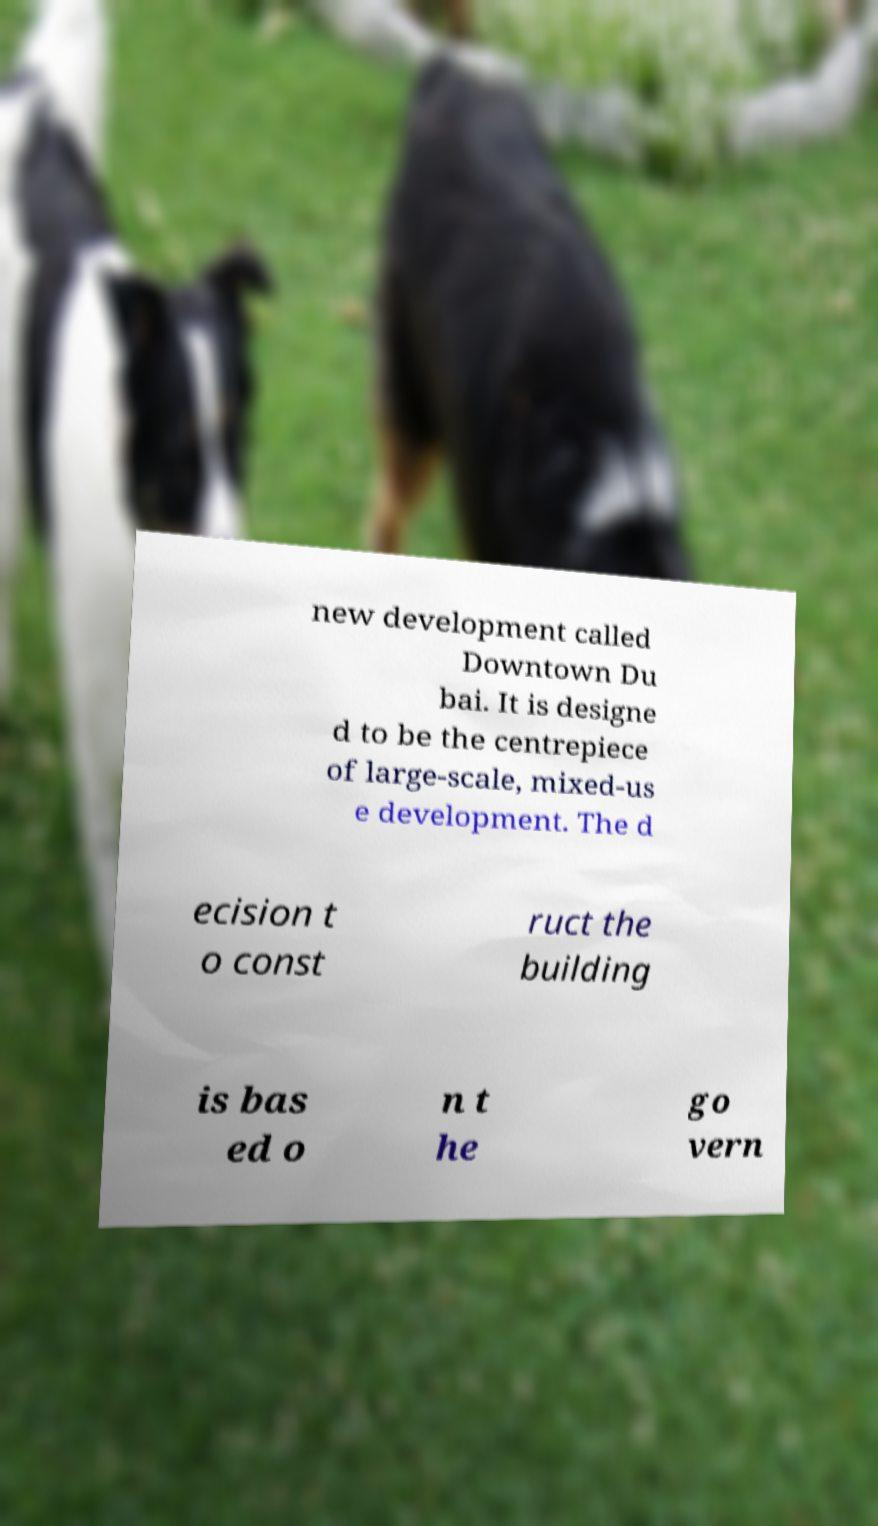Could you assist in decoding the text presented in this image and type it out clearly? new development called Downtown Du bai. It is designe d to be the centrepiece of large-scale, mixed-us e development. The d ecision t o const ruct the building is bas ed o n t he go vern 